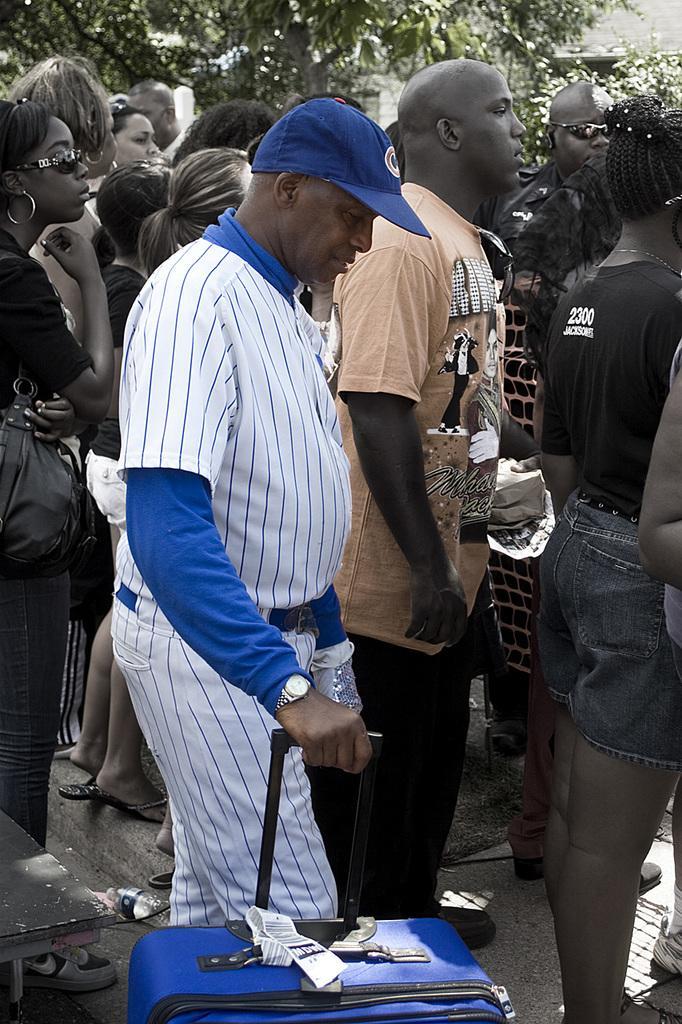Please provide a concise description of this image. In this image we can see there are so many people standing in a group. where one of them is holding a luggage bag, behind them there are trees and buildings. 